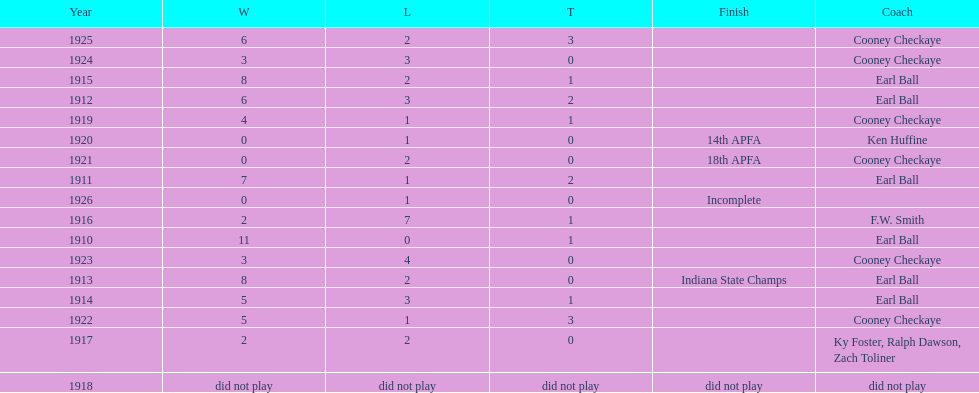Who coached the muncie flyers to an indiana state championship? Earl Ball. 